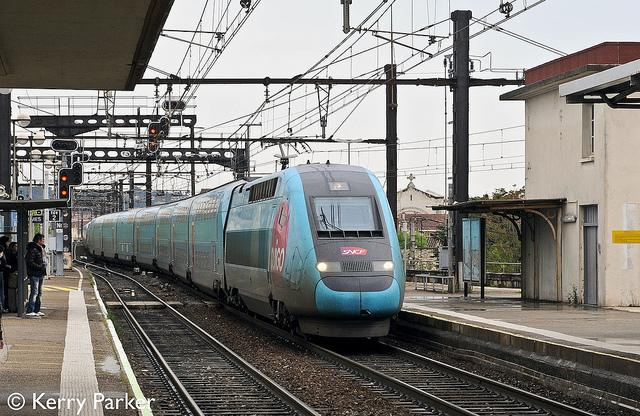The main color of this vehicle is the same color as what? sky 